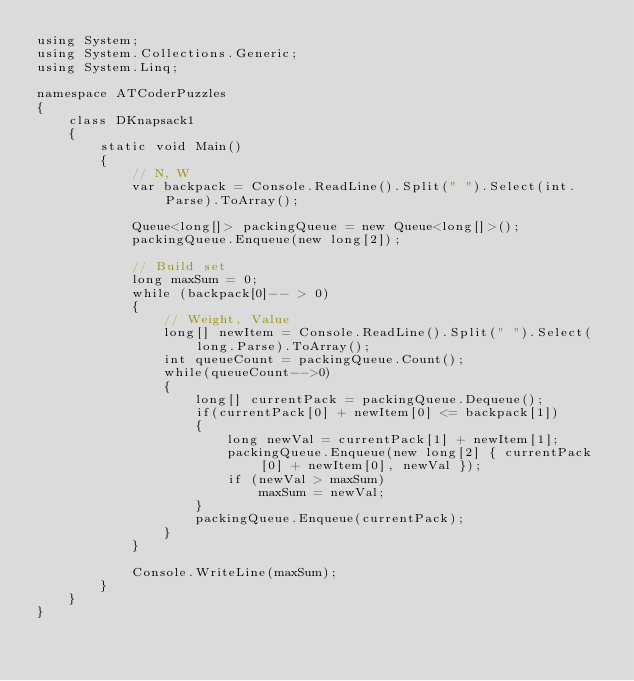<code> <loc_0><loc_0><loc_500><loc_500><_C#_>using System;
using System.Collections.Generic;
using System.Linq;

namespace ATCoderPuzzles
{
    class DKnapsack1
    {
        static void Main()
        {
            // N, W
            var backpack = Console.ReadLine().Split(" ").Select(int.Parse).ToArray();

            Queue<long[]> packingQueue = new Queue<long[]>();
            packingQueue.Enqueue(new long[2]);

            // Build set
            long maxSum = 0;
            while (backpack[0]-- > 0)
            {
                // Weight, Value
                long[] newItem = Console.ReadLine().Split(" ").Select(long.Parse).ToArray();
                int queueCount = packingQueue.Count();
                while(queueCount-->0)
                {
                    long[] currentPack = packingQueue.Dequeue();
                    if(currentPack[0] + newItem[0] <= backpack[1])
                    {
                        long newVal = currentPack[1] + newItem[1];
                        packingQueue.Enqueue(new long[2] { currentPack[0] + newItem[0], newVal });
                        if (newVal > maxSum)
                            maxSum = newVal;
                    }
                    packingQueue.Enqueue(currentPack);
                }
            }

            Console.WriteLine(maxSum);
        }
    }
}
</code> 